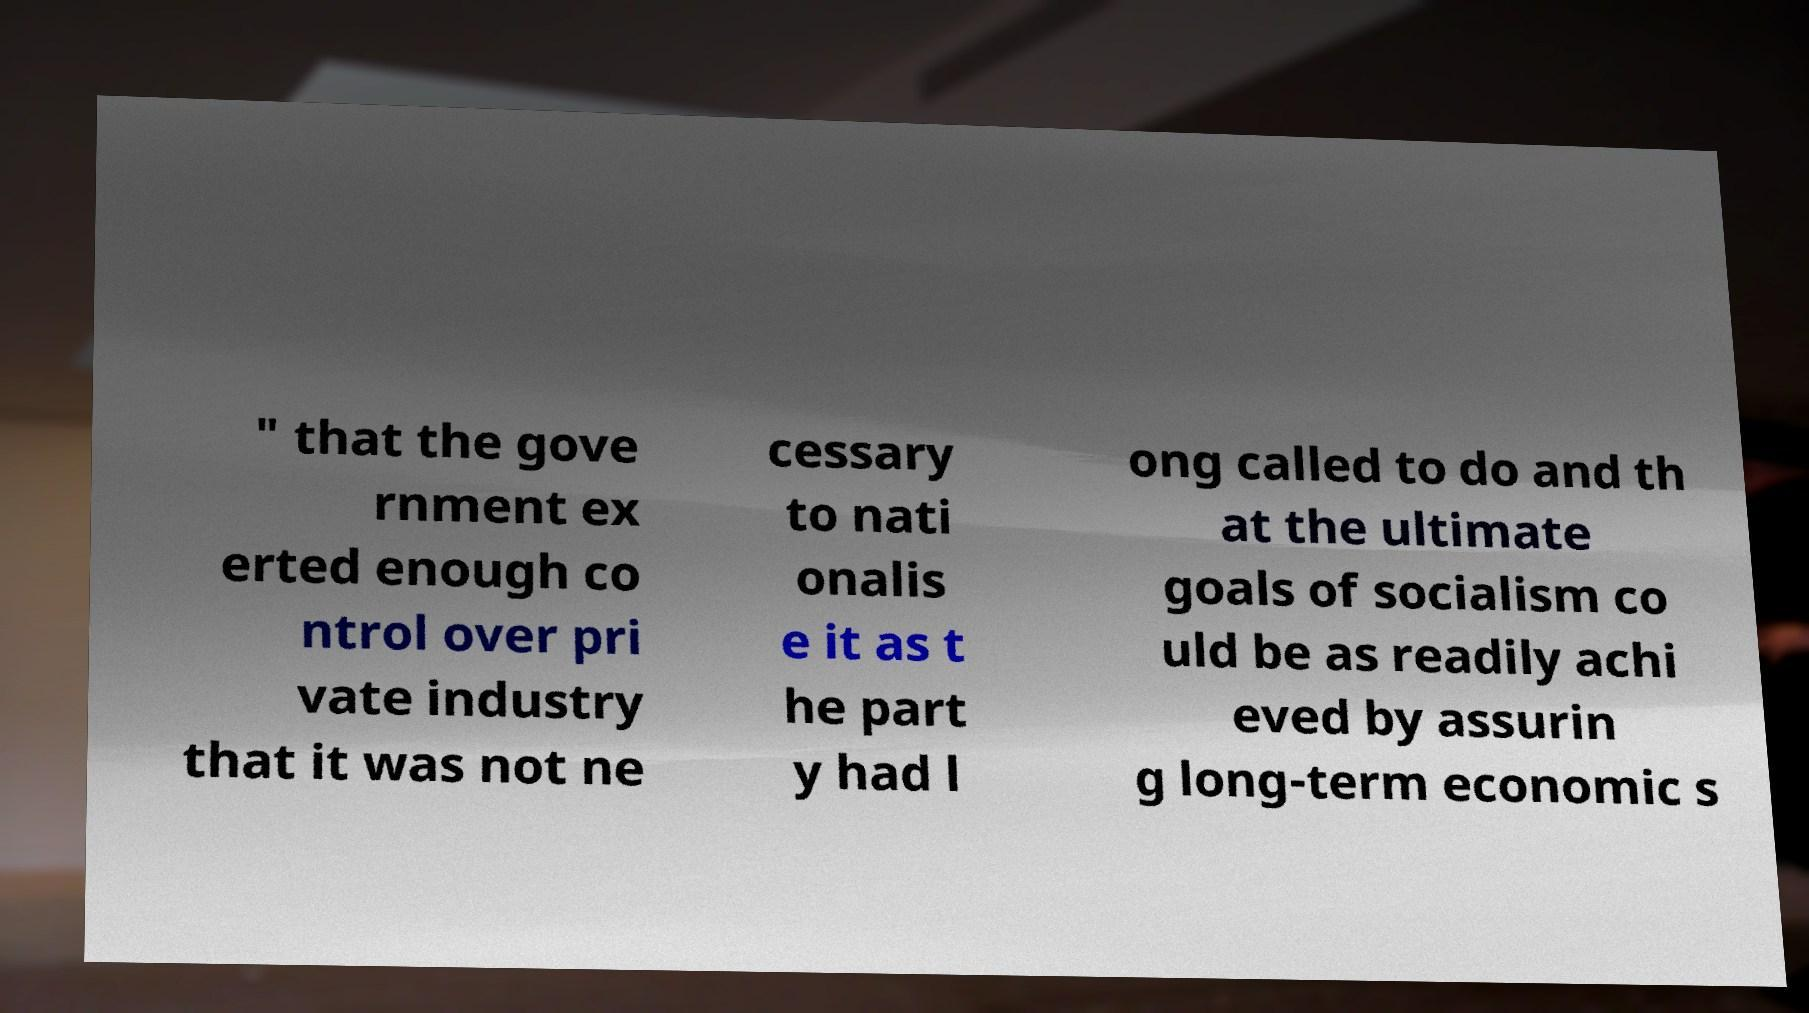Please read and relay the text visible in this image. What does it say? " that the gove rnment ex erted enough co ntrol over pri vate industry that it was not ne cessary to nati onalis e it as t he part y had l ong called to do and th at the ultimate goals of socialism co uld be as readily achi eved by assurin g long-term economic s 